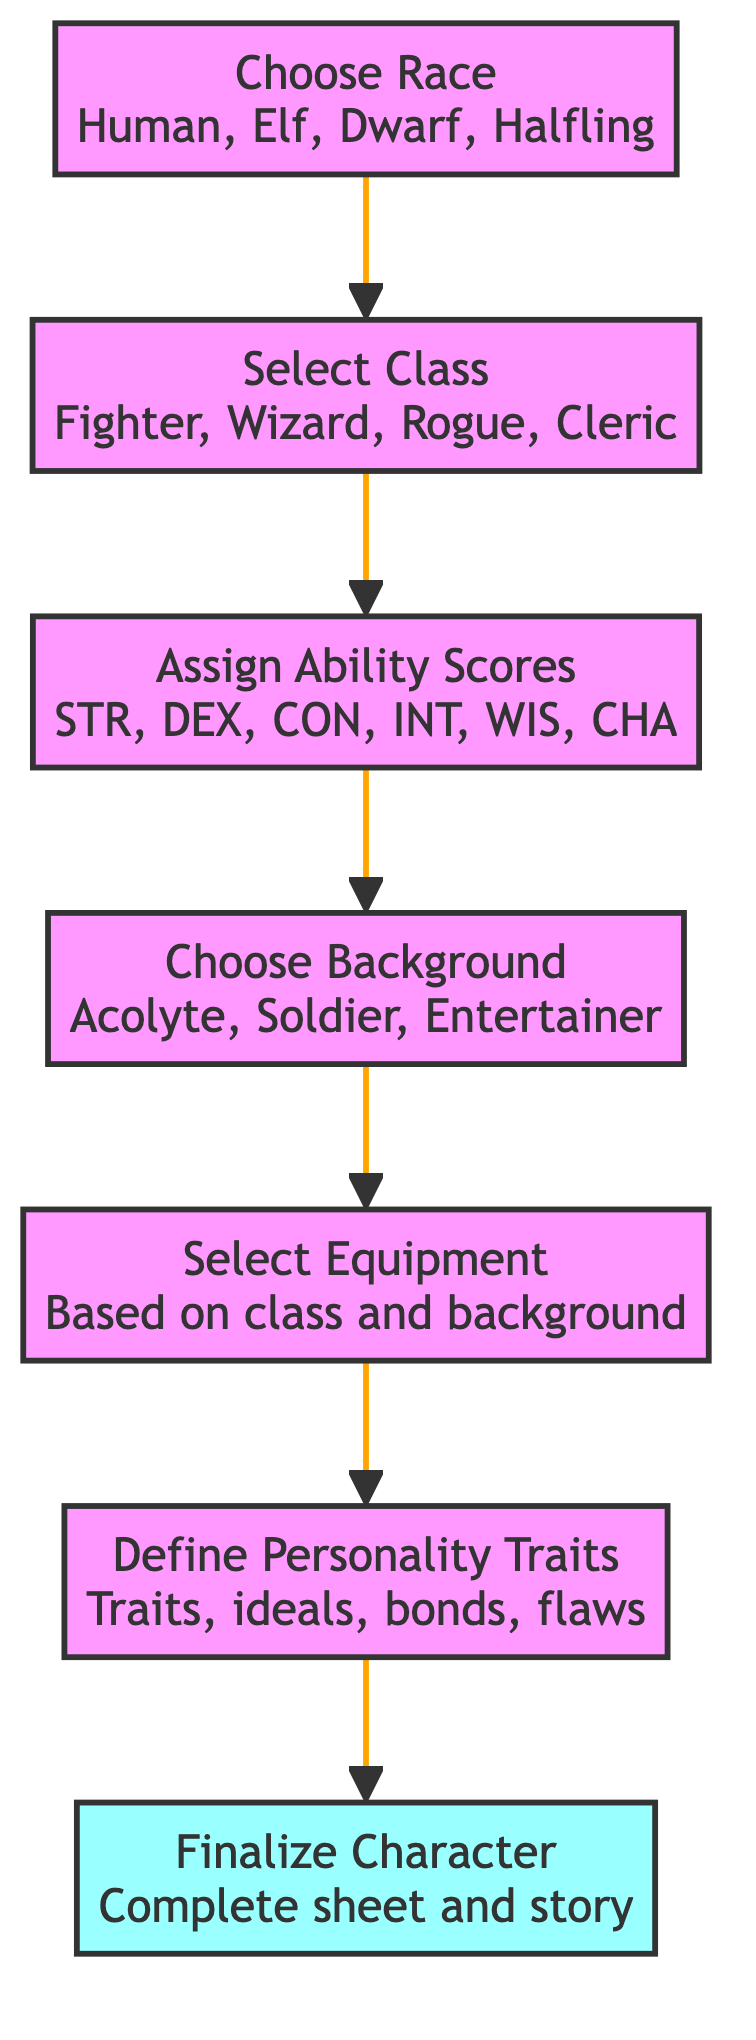What is the first step in the character creation process? The first step in the character creation process is represented by the node "Choose Race," which involves selecting a race for the character.
Answer: Choose Race How many nodes are in this directed graph? The diagram contains a total of 7 nodes, each representing a specific step in the character creation process.
Answer: 7 What comes after "Select Class"? The flow from "Select Class" leads directly to the next step, which is "Assign Ability Scores."
Answer: Assign Ability Scores What does the final step entail? The last step is "Finalize Character," where you complete your character sheet and story.
Answer: Finalize Character Which step directly follows "Choose Background"? The step that directly follows "Choose Background" is "Select Equipment," based on the choices made earlier in the process.
Answer: Select Equipment What is the relationship between "Assign Ability Scores" and "Choose Background"? There is a sequential relationship; "Assign Ability Scores" comes immediately before "Choose Background" in the flow of the character creation process.
Answer: Sequential relationship How many edges are in the directed graph? The diagram features 6 edges, each representing a connection between two consecutive steps in the character creation process.
Answer: 6 What element is included in the "Define Personality Traits" step? The "Define Personality Traits" step includes creating traits, ideals, bonds, and flaws to develop the character's personality.
Answer: Traits, ideals, bonds, flaws 